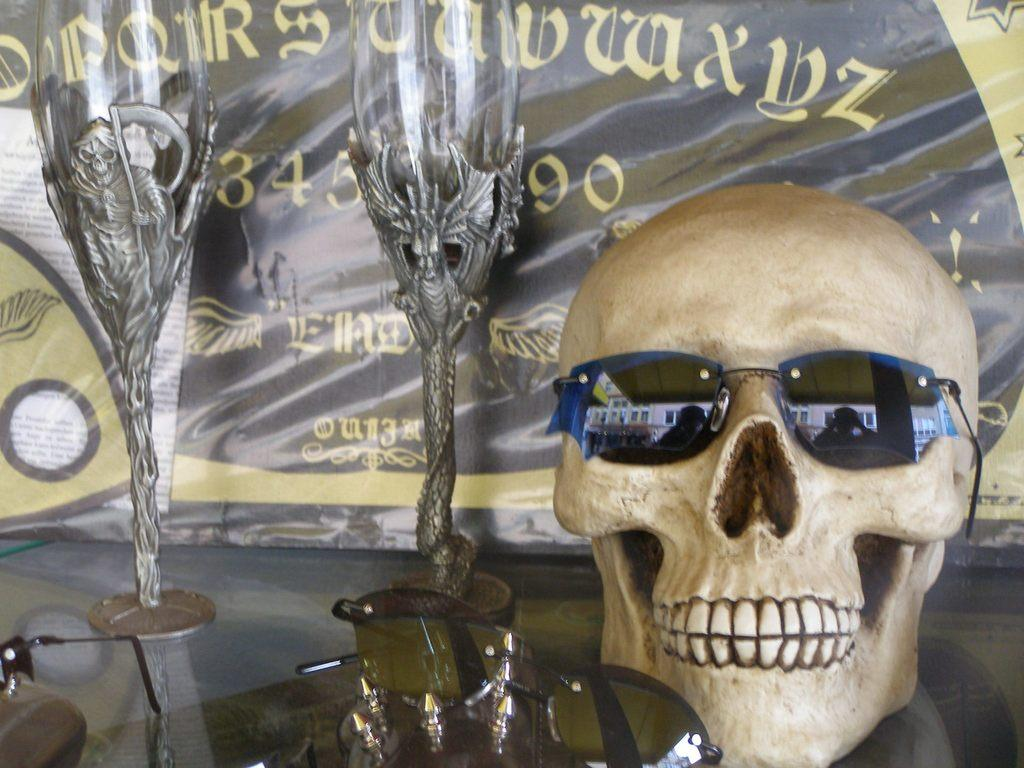What is the main subject of the image? The main subject of the image is a skull with goggles. What other items related to vision can be seen in the image? There are additional goggles and glasses in the image. What is visible in the background of the image? There is a banner in the background of the image. What is written on the banner? There is writing on the banner, but the specific message cannot be determined from the image alone. How many waves can be seen crashing on the shore in the image? There are no waves or shore visible in the image; it features a skull with goggles and other vision-related items. 